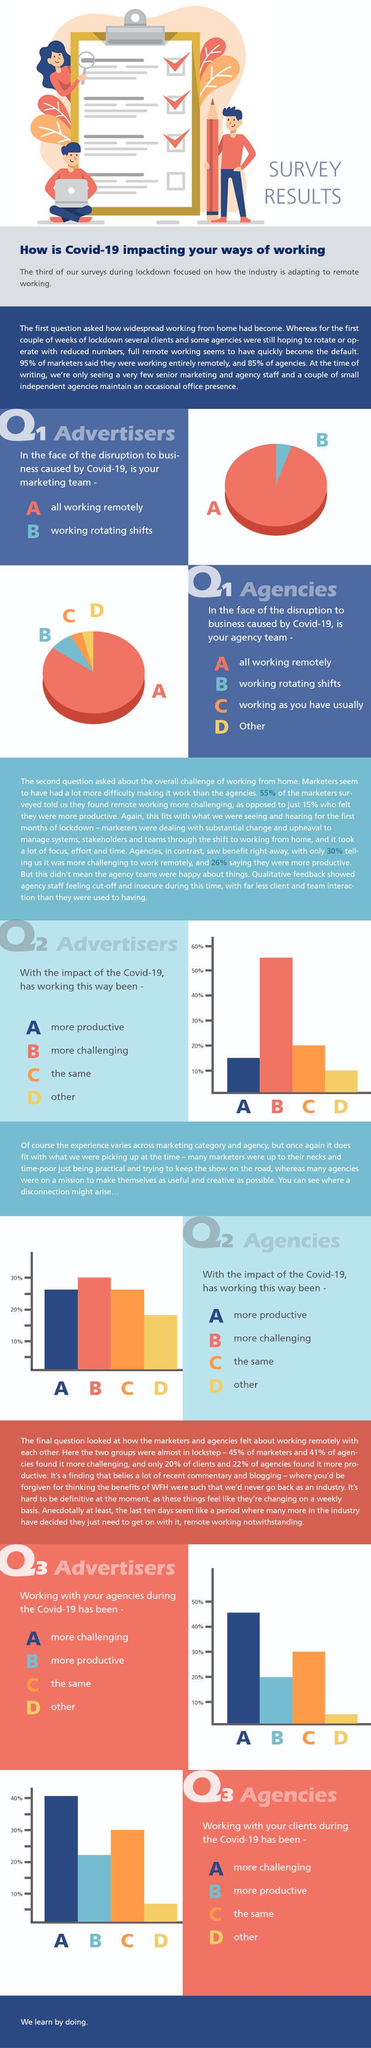Identify some key points in this picture. The second most selected option by people who participated in the survey of Q3 advertisers is the same as the second most selected option by people who participated in the survey of Q1 advertisers. According to the survey of Q2 Advertisers, 15% of people reported that their work has been more productive due to the impact of Covid-19. According to the survey of Q2 Advertisers, 55% of people voted that their work has been more challenging due to the impact of COVID-19. The option preferred by the majority of participants in the Q3 Advertiser survey is... According to the survey of Q3 Advertisers, 45% of people reported that working with agencies has been more challenging during the COVID-19 pandemic. 